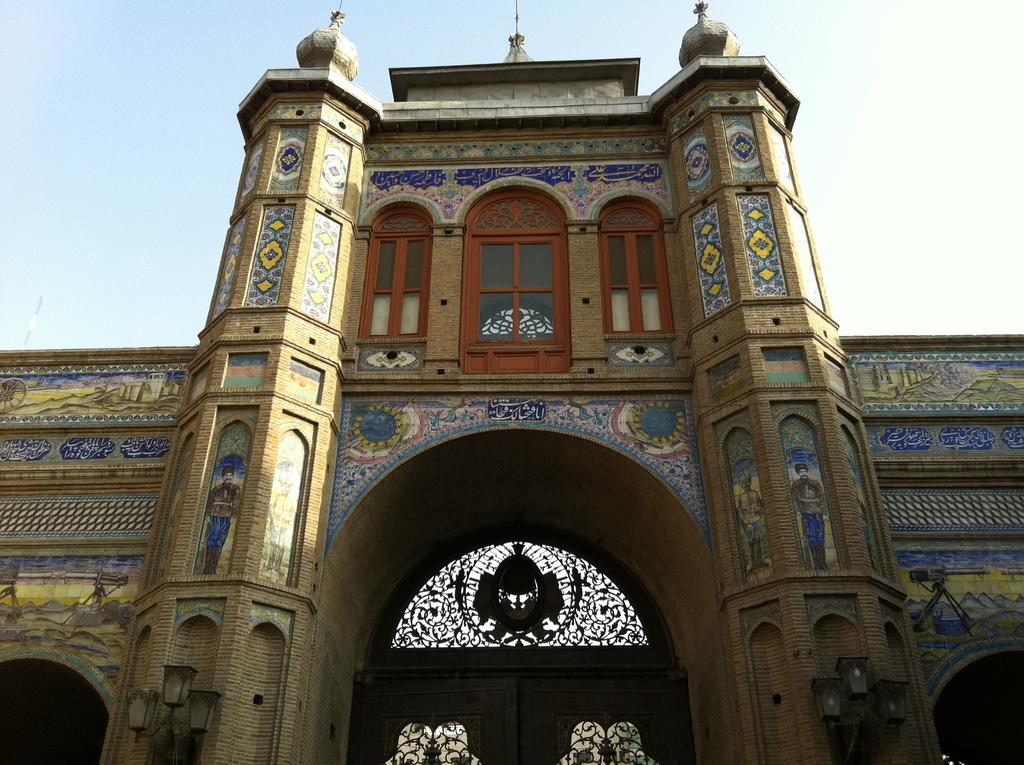What is the main subject in the center of the image? There is a building in the center of the image. What can be seen at the top of the image? The sky is visible at the top of the image. Where are the scissors located in the image? There are no scissors present in the image. Can you describe how the building is biting into the sky in the image? The building is not biting into the sky; it is a stationary structure, and the sky is visible above it. 